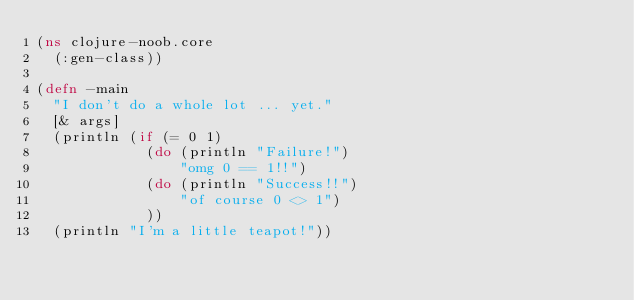<code> <loc_0><loc_0><loc_500><loc_500><_Clojure_>(ns clojure-noob.core
  (:gen-class))

(defn -main
  "I don't do a whole lot ... yet."
  [& args]
  (println (if (= 0 1)
             (do (println "Failure!")
                 "omg 0 == 1!!")
             (do (println "Success!!")
                 "of course 0 <> 1")
             ))
  (println "I'm a little teapot!"))


</code> 